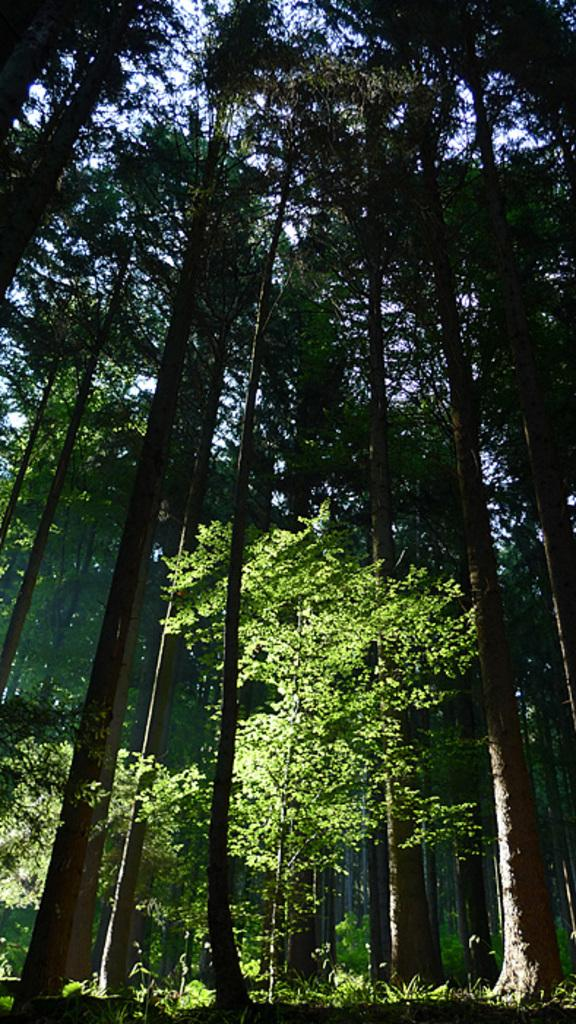What type of vegetation can be seen in the image? There are trees in the image. What can be seen in the sky in the image? There are clouds visible in the sky. What type of potato is being developed in the image? There is no potato or development process present in the image. What smell can be detected in the image? The image does not provide any information about smells, as it only shows trees and clouds. 